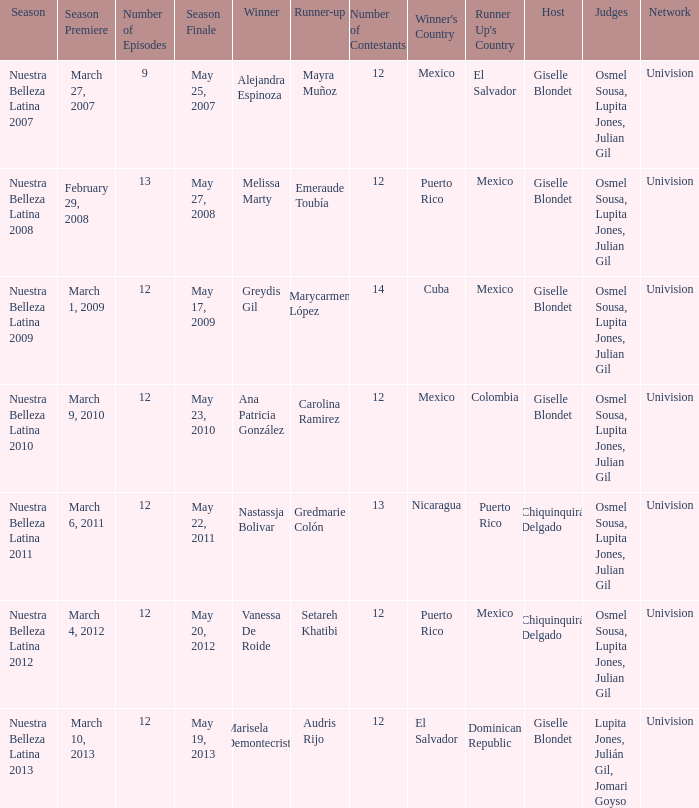What season's premiere had puerto rico winning on May 20, 2012? March 4, 2012. 